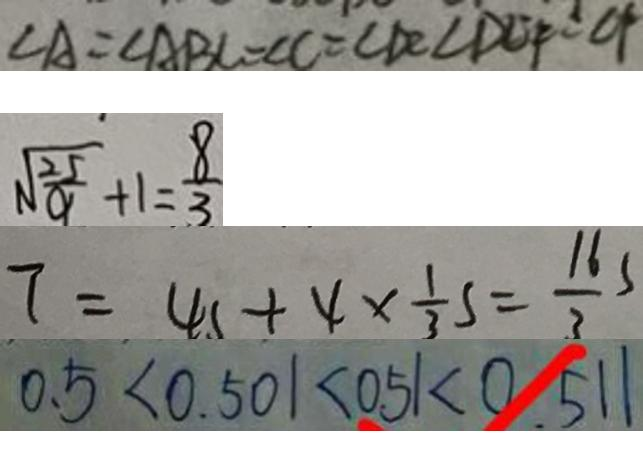Convert formula to latex. <formula><loc_0><loc_0><loc_500><loc_500>\angle A = \angle A B C = \angle C = \angle D C \angle D C F = C F 
 \sqrt { \frac { 2 5 } { 9 } } + 1 = \frac { 8 } { 3 } 
 7 = 4 s \times 4 \times \frac { 1 } { 3 } s = \frac { 1 6 } { 3 } s 
 0 . 5 < 0 . 5 0 1 < 0 . 5 1 < 0 . 5 1 1</formula> 